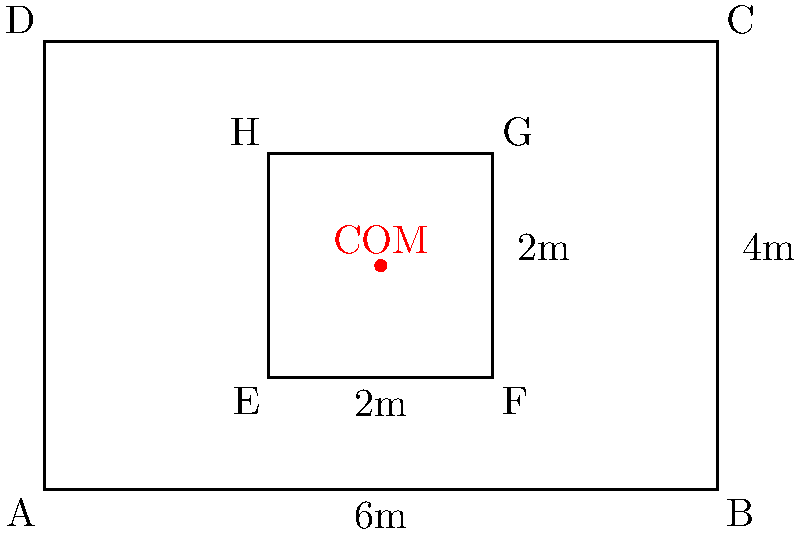In your gym, you've designed a custom weight rack system consisting of a sturdy outer frame and an adjustable inner platform. The outer frame forms a rectangle measuring 6m by 4m, while the inner platform is a smaller rectangle measuring 2m by 2m, centered within the frame. Assuming the frame and platform have uniform density, determine the coordinates of the center of mass (COM) for this entire setup. Use the bottom-left corner of the outer frame as the origin (0,0) of your coordinate system. To find the center of mass of this composite system, we'll follow these steps:

1) First, let's identify the two components:
   - Outer frame: a hollow rectangle
   - Inner platform: a solid rectangle

2) For the outer frame:
   - Dimensions: 6m x 4m (outer), 4m x 2m (inner hole)
   - Area: $A_1 = 6 \cdot 4 - 4 \cdot 2 = 24 - 8 = 16$ m²
   - Center: $(x_1, y_1) = (3, 2)$

3) For the inner platform:
   - Dimensions: 2m x 2m
   - Area: $A_2 = 2 \cdot 2 = 4$ m²
   - Center: $(x_2, y_2) = (3, 2)$

4) The formula for the center of mass of a composite system is:
   $x_{COM} = \frac{A_1x_1 + A_2x_2}{A_1 + A_2}$
   $y_{COM} = \frac{A_1y_1 + A_2y_2}{A_1 + A_2}$

5) Substituting our values:
   $x_{COM} = \frac{16 \cdot 3 + 4 \cdot 3}{16 + 4} = \frac{60}{20} = 3$
   $y_{COM} = \frac{16 \cdot 2 + 4 \cdot 2}{16 + 4} = \frac{40}{20} = 2$

6) Therefore, the center of mass is at the point (3, 2).

This result makes intuitive sense, as it's at the center of both the outer frame and the inner platform, reflecting the symmetry of the entire setup.
Answer: (3, 2) 